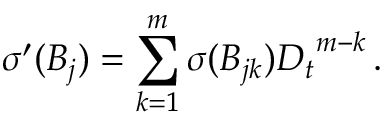<formula> <loc_0><loc_0><loc_500><loc_500>{ \sigma } ^ { \prime } ( B _ { j } ) = \sum _ { k = 1 } ^ { m } { \sigma } ( B _ { j k } ) { D _ { t } } ^ { m - k } \, .</formula> 